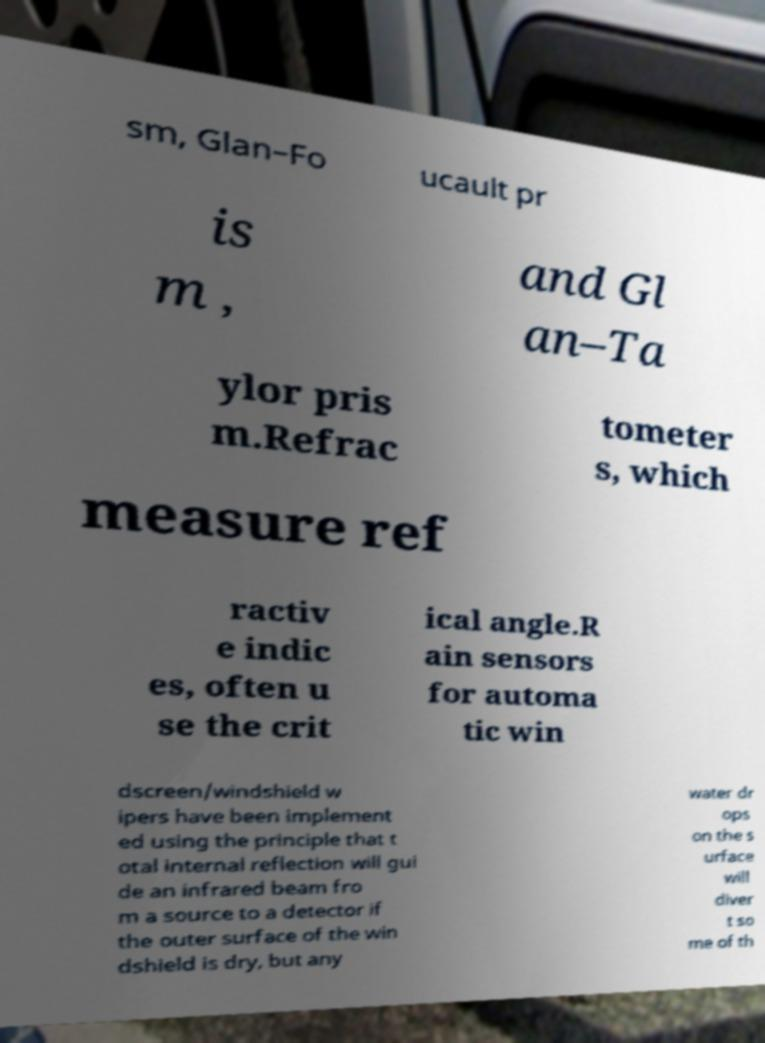Can you accurately transcribe the text from the provided image for me? sm, Glan–Fo ucault pr is m , and Gl an–Ta ylor pris m.Refrac tometer s, which measure ref ractiv e indic es, often u se the crit ical angle.R ain sensors for automa tic win dscreen/windshield w ipers have been implement ed using the principle that t otal internal reflection will gui de an infrared beam fro m a source to a detector if the outer surface of the win dshield is dry, but any water dr ops on the s urface will diver t so me of th 